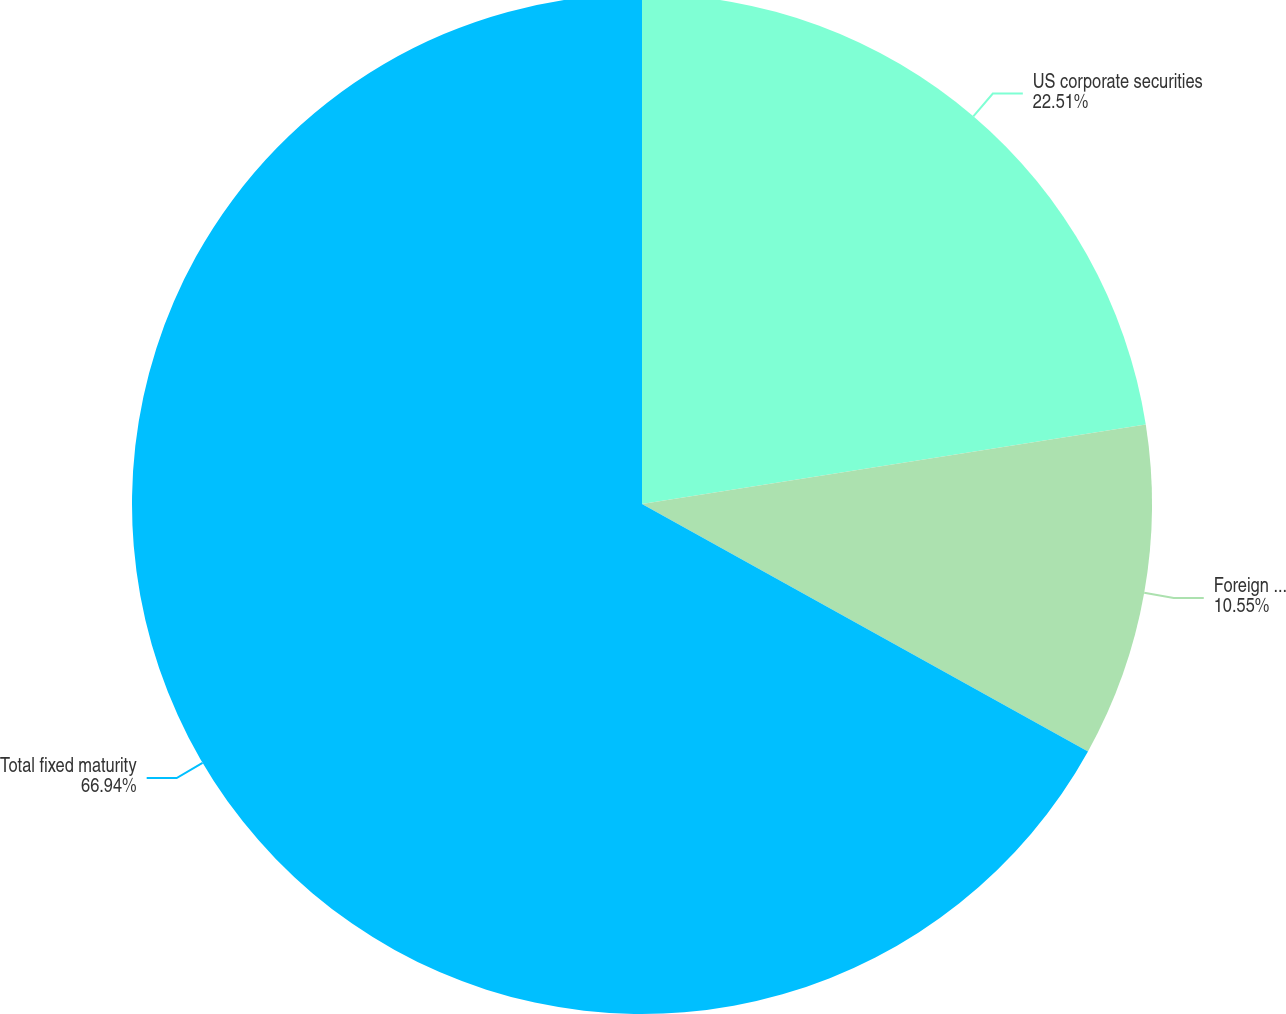Convert chart. <chart><loc_0><loc_0><loc_500><loc_500><pie_chart><fcel>US corporate securities<fcel>Foreign corporate securities<fcel>Total fixed maturity<nl><fcel>22.51%<fcel>10.55%<fcel>66.94%<nl></chart> 